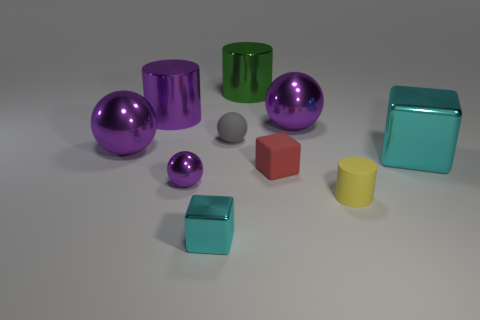Subtract all tiny cubes. How many cubes are left? 1 Subtract all balls. How many objects are left? 6 Subtract all cyan blocks. How many blocks are left? 1 Subtract 2 blocks. How many blocks are left? 1 Add 7 large purple shiny spheres. How many large purple shiny spheres are left? 9 Add 10 tiny metallic cylinders. How many tiny metallic cylinders exist? 10 Subtract 1 red cubes. How many objects are left? 9 Subtract all purple cubes. Subtract all purple cylinders. How many cubes are left? 3 Subtract all blue cubes. How many yellow cylinders are left? 1 Subtract all purple cylinders. Subtract all yellow matte cylinders. How many objects are left? 8 